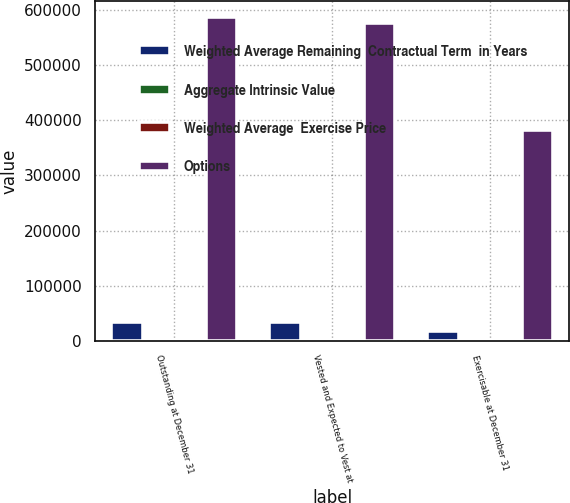Convert chart to OTSL. <chart><loc_0><loc_0><loc_500><loc_500><stacked_bar_chart><ecel><fcel>Outstanding at December 31<fcel>Vested and Expected to Vest at<fcel>Exercisable at December 31<nl><fcel>Weighted Average Remaining  Contractual Term  in Years<fcel>34820<fcel>33887<fcel>18436<nl><fcel>Aggregate Intrinsic Value<fcel>30.31<fcel>30.14<fcel>26.12<nl><fcel>Weighted Average  Exercise Price<fcel>6<fcel>6<fcel>4<nl><fcel>Options<fcel>587113<fcel>576570<fcel>382295<nl></chart> 